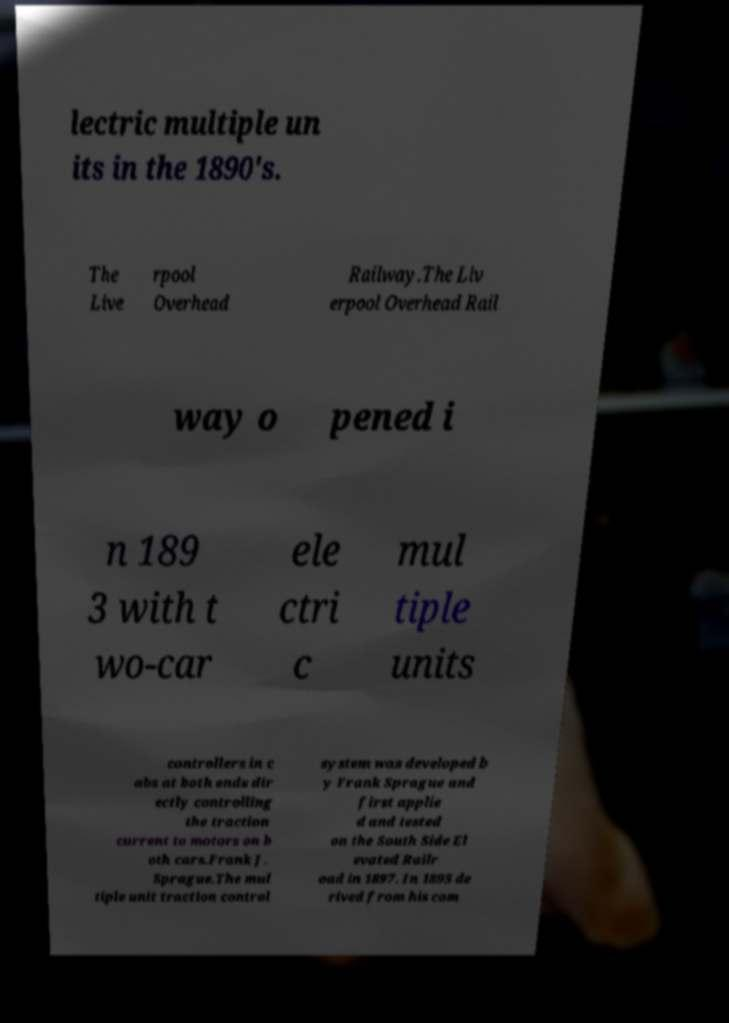Could you extract and type out the text from this image? lectric multiple un its in the 1890's. The Live rpool Overhead Railway.The Liv erpool Overhead Rail way o pened i n 189 3 with t wo-car ele ctri c mul tiple units controllers in c abs at both ends dir ectly controlling the traction current to motors on b oth cars.Frank J. Sprague.The mul tiple unit traction control system was developed b y Frank Sprague and first applie d and tested on the South Side El evated Railr oad in 1897. In 1895 de rived from his com 